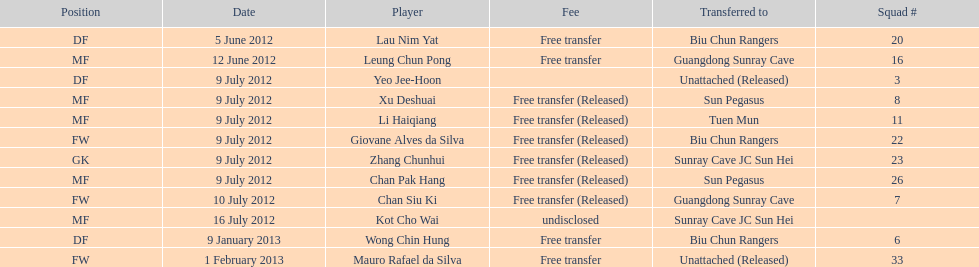Which team did lau nim yat play for after he was transferred? Biu Chun Rangers. 